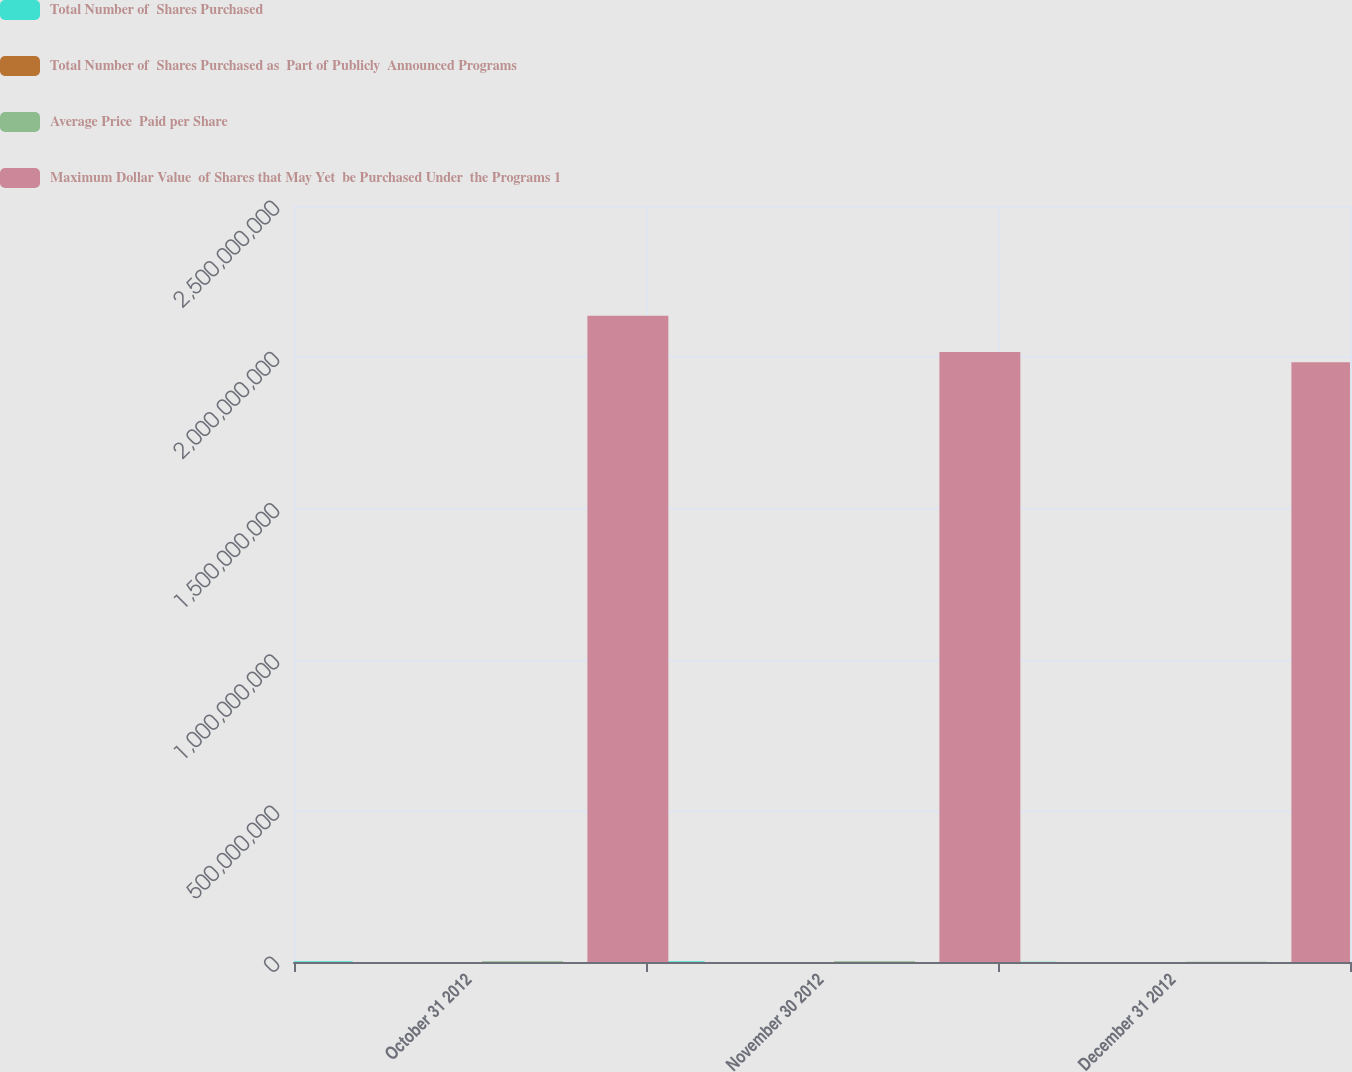<chart> <loc_0><loc_0><loc_500><loc_500><stacked_bar_chart><ecel><fcel>October 31 2012<fcel>November 30 2012<fcel>December 31 2012<nl><fcel>Total Number of  Shares Purchased<fcel>2.1e+06<fcel>2.4e+06<fcel>665000<nl><fcel>Total Number of  Shares Purchased as  Part of Publicly  Announced Programs<fcel>48.67<fcel>49.81<fcel>52.07<nl><fcel>Average Price  Paid per Share<fcel>2.1e+06<fcel>2.4e+06<fcel>665000<nl><fcel>Maximum Dollar Value  of Shares that May Yet  be Purchased Under  the Programs 1<fcel>2.13711e+09<fcel>2.01757e+09<fcel>1.98294e+09<nl></chart> 